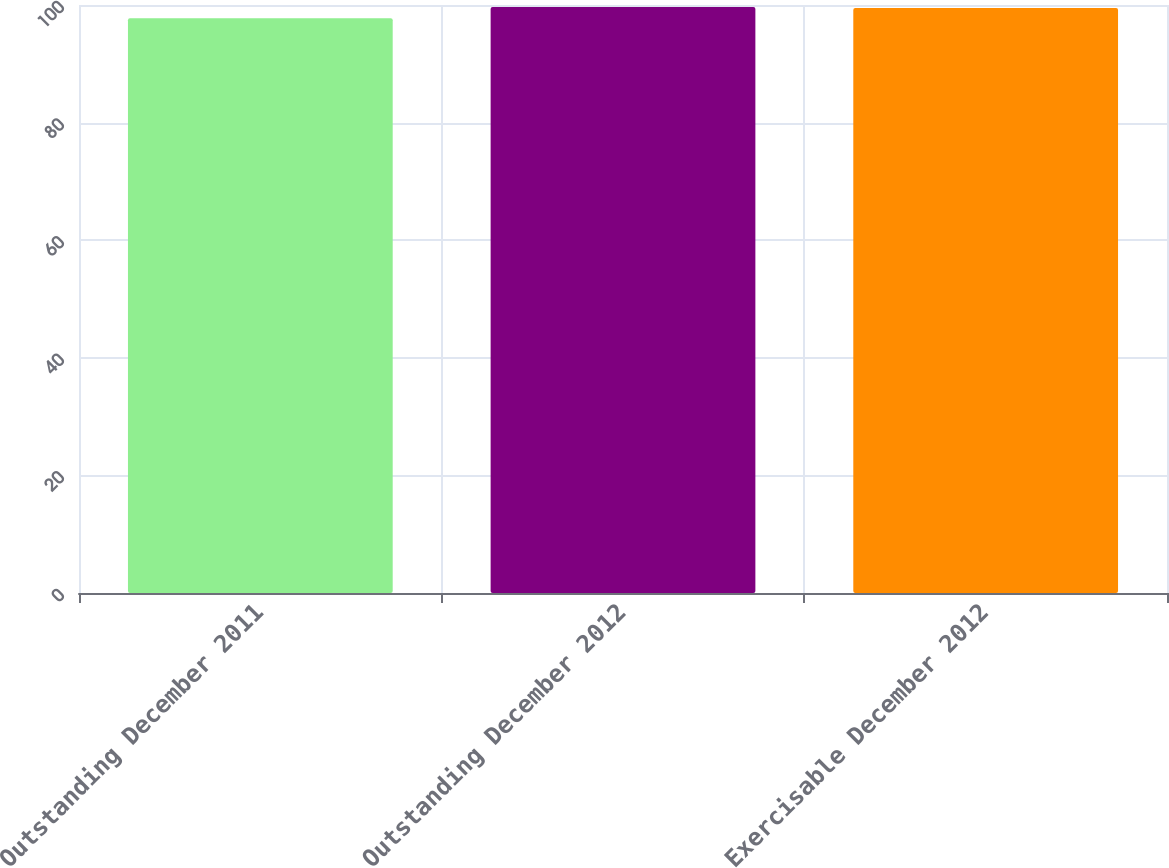Convert chart to OTSL. <chart><loc_0><loc_0><loc_500><loc_500><bar_chart><fcel>Outstanding December 2011<fcel>Outstanding December 2012<fcel>Exercisable December 2012<nl><fcel>97.76<fcel>99.66<fcel>99.49<nl></chart> 